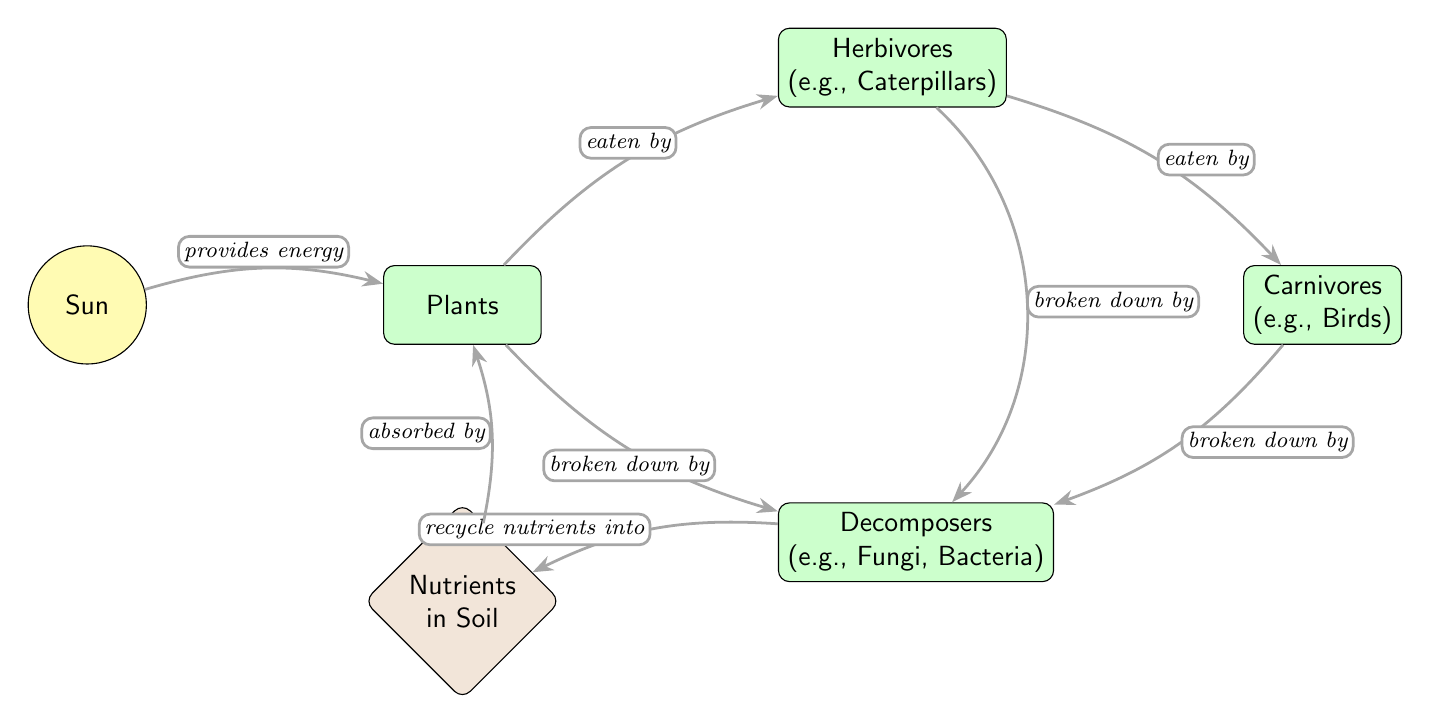What organisms are primary producers in this diagram? In the diagram, the node labeled "Plants" directly receives energy from the "Sun," indicating that they are the primary producers that convert sunlight into energy through photosynthesis.
Answer: Plants Which organisms are broken down by decomposers? The diagram shows arrows leading from both "Carnivores" and "Herbivores" to "Decomposers," indicating that these organisms are broken down by decomposers. Additionally, "Plants" also has an arrow leading to "Decomposers," which confirms that they too are broken down.
Answer: Carnivores, Herbivores, Plants What is recycled into nutrients by decomposers? The diagram specifies that "Decomposers" recycle organic matter into "Nutrients" in the soil, highlighting their essential role in nutrient cycling within the ecosystem.
Answer: Nutrients How many total organisms are present in this food chain diagram? Counting the nodes representing organisms, we find "Plants," "Herbivores," "Carnivores," and "Decomposers," totaling four distinct organisms depicted in the diagram.
Answer: 4 What role does the sun play in this food chain? The "Sun" node is connected to "Plants" with an arrow that indicates it provides energy essential for photosynthesis, making it a crucial element for the beginning of this food chain.
Answer: Provides energy What do nutrients in the soil do for plants? The diagram indicates that "Nutrients" are absorbed by "Plants," which means they are essential for plant growth and development, completing the nutrient cycle initiated by decomposers.
Answer: Absorbed by Which organism sits at the top of this food chain? In the diagram, "Carnivores" are positioned above "Herbivores," indicating that they are at the top of the depicted food chain, as they consume herbivores.
Answer: Carnivores 